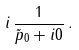Convert formula to latex. <formula><loc_0><loc_0><loc_500><loc_500>i \, \frac { 1 } { \tilde { p } _ { 0 } + i 0 } \, .</formula> 